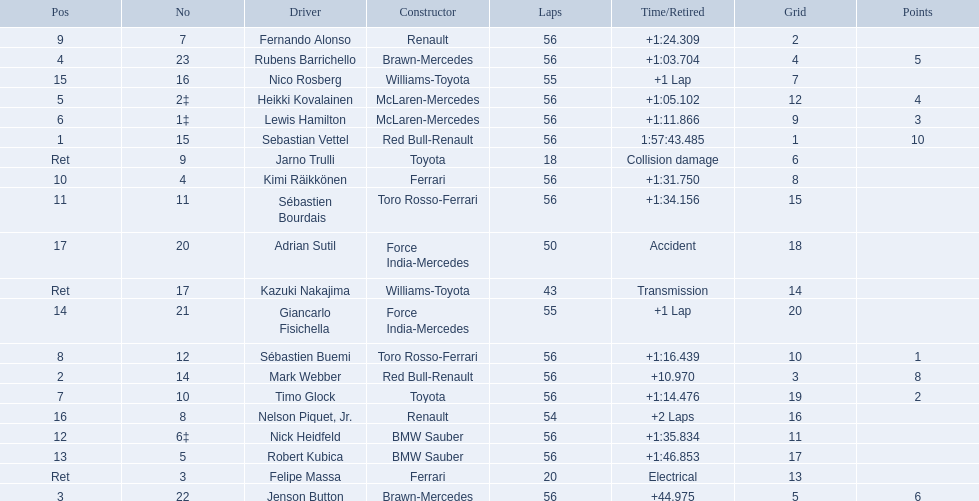Which drivers took part in the 2009 chinese grand prix? Sebastian Vettel, Mark Webber, Jenson Button, Rubens Barrichello, Heikki Kovalainen, Lewis Hamilton, Timo Glock, Sébastien Buemi, Fernando Alonso, Kimi Räikkönen, Sébastien Bourdais, Nick Heidfeld, Robert Kubica, Giancarlo Fisichella, Nico Rosberg, Nelson Piquet, Jr., Adrian Sutil, Kazuki Nakajima, Felipe Massa, Jarno Trulli. Of these, who completed all 56 laps? Sebastian Vettel, Mark Webber, Jenson Button, Rubens Barrichello, Heikki Kovalainen, Lewis Hamilton, Timo Glock, Sébastien Buemi, Fernando Alonso, Kimi Räikkönen, Sébastien Bourdais, Nick Heidfeld, Robert Kubica. Of these, which did ferrari not participate as a constructor? Sebastian Vettel, Mark Webber, Jenson Button, Rubens Barrichello, Heikki Kovalainen, Lewis Hamilton, Timo Glock, Fernando Alonso, Kimi Räikkönen, Nick Heidfeld, Robert Kubica. Of the remaining, which is in pos 1? Sebastian Vettel. 